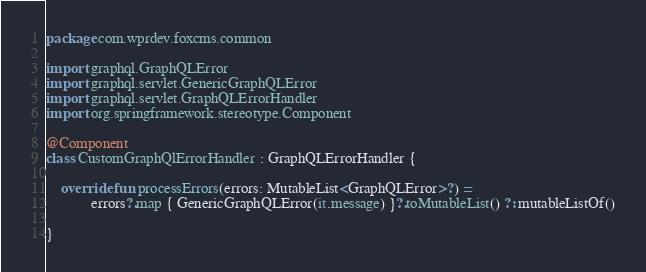<code> <loc_0><loc_0><loc_500><loc_500><_Kotlin_>package com.wprdev.foxcms.common

import graphql.GraphQLError
import graphql.servlet.GenericGraphQLError
import graphql.servlet.GraphQLErrorHandler
import org.springframework.stereotype.Component

@Component
class CustomGraphQlErrorHandler : GraphQLErrorHandler {

    override fun processErrors(errors: MutableList<GraphQLError>?) =
            errors?.map { GenericGraphQLError(it.message) }?.toMutableList() ?: mutableListOf()

}</code> 